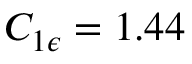<formula> <loc_0><loc_0><loc_500><loc_500>C _ { 1 \epsilon } = 1 . 4 4</formula> 